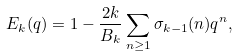Convert formula to latex. <formula><loc_0><loc_0><loc_500><loc_500>E _ { k } ( q ) = 1 - \frac { 2 k } { B _ { k } } \sum _ { n \geq 1 } \sigma _ { k - 1 } ( n ) q ^ { n } ,</formula> 